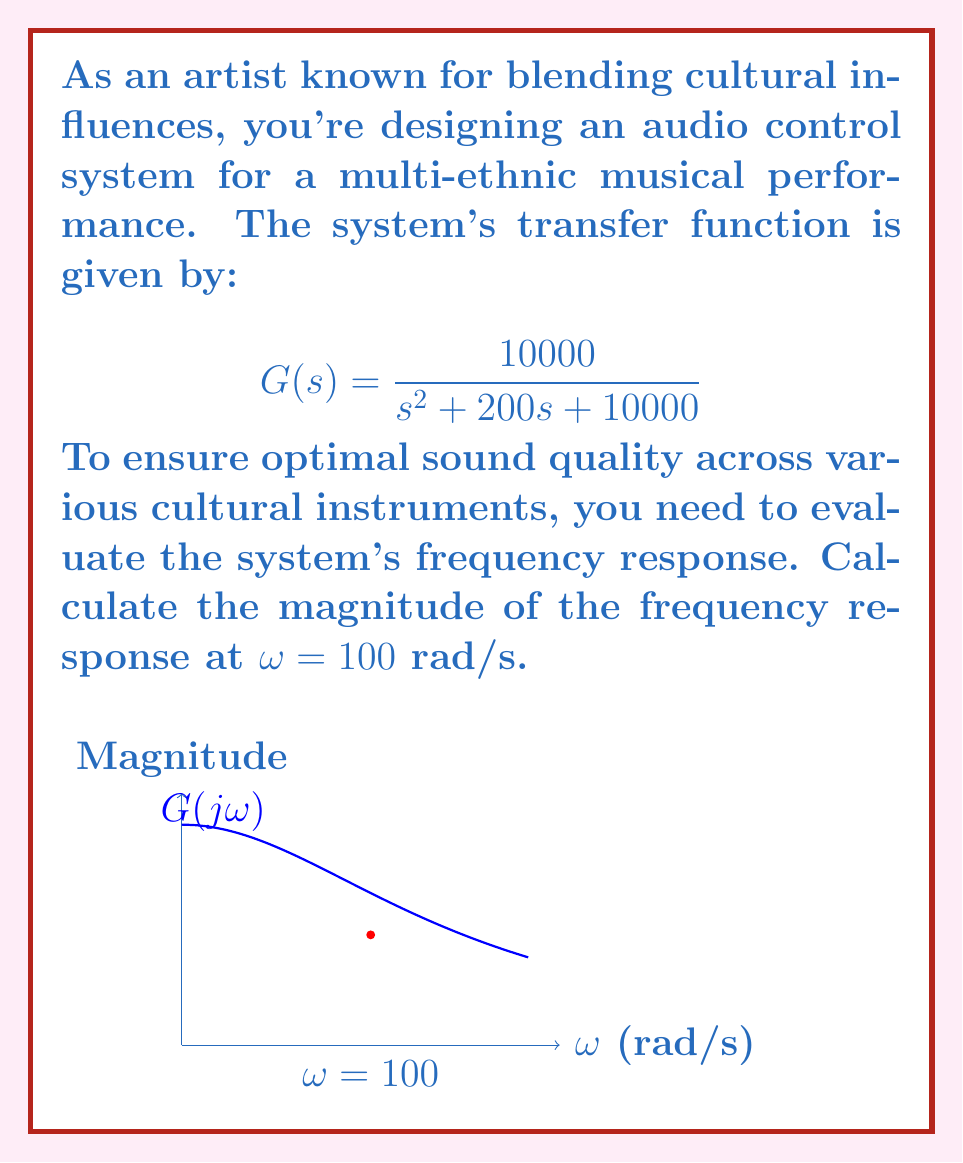Give your solution to this math problem. To evaluate the frequency response, we follow these steps:

1) The frequency response is obtained by substituting $s$ with $jω$ in the transfer function:

   $$G(jω) = \frac{10000}{(jω)^2 + 200(jω) + 10000}$$

2) For ω = 100 rad/s:

   $$G(j100) = \frac{10000}{(j100)^2 + 200(j100) + 10000}$$

3) Simplify the denominator:

   $$G(j100) = \frac{10000}{-10000 + 20000j + 10000} = \frac{10000}{20000j}$$

4) The magnitude of the frequency response is given by:

   $$|G(jω)| = \frac{|10000|}{|\sqrt{(-ω^2+10000)^2+(200ω)^2}|}$$

5) Substituting ω = 100:

   $$|G(j100)| = \frac{10000}{\sqrt{0^2+(20000)^2}} = \frac{10000}{20000} = 0.5$$

Thus, the magnitude of the frequency response at ω = 100 rad/s is 0.5.
Answer: 0.5 